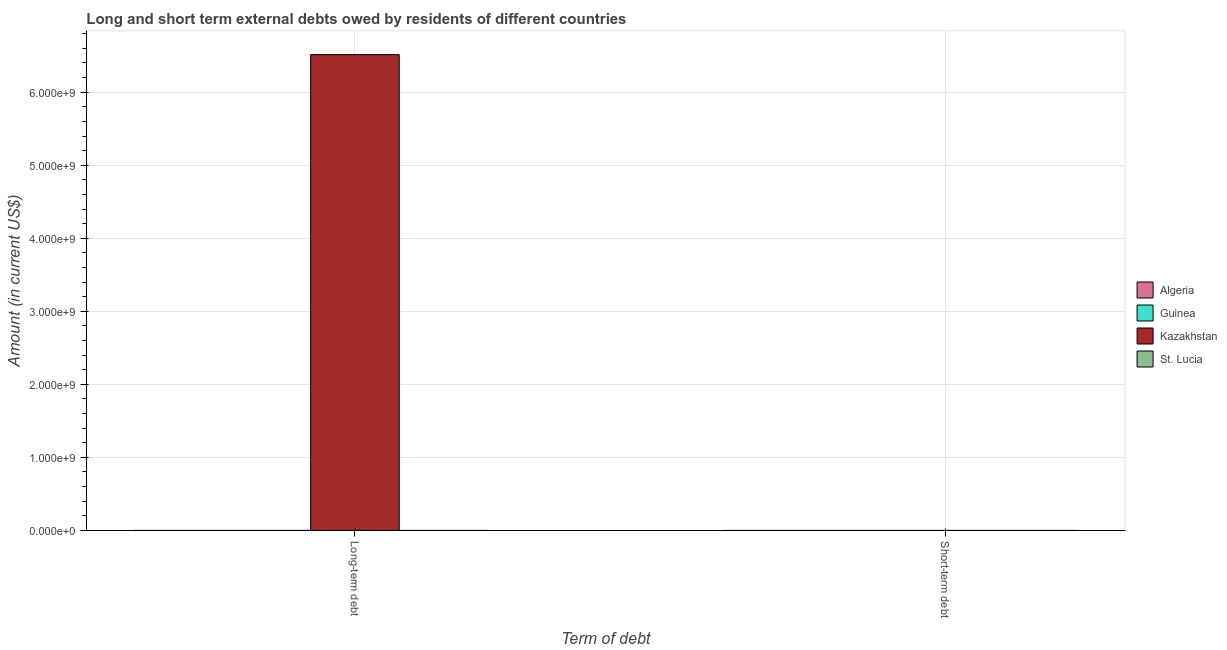Are the number of bars per tick equal to the number of legend labels?
Provide a succinct answer. No. Are the number of bars on each tick of the X-axis equal?
Your answer should be very brief. No. How many bars are there on the 2nd tick from the left?
Give a very brief answer. 0. How many bars are there on the 2nd tick from the right?
Offer a terse response. 1. What is the label of the 1st group of bars from the left?
Your response must be concise. Long-term debt. Across all countries, what is the maximum long-term debts owed by residents?
Provide a succinct answer. 6.51e+09. Across all countries, what is the minimum short-term debts owed by residents?
Make the answer very short. 0. In which country was the long-term debts owed by residents maximum?
Your answer should be very brief. Kazakhstan. What is the total short-term debts owed by residents in the graph?
Your answer should be compact. 0. What is the average long-term debts owed by residents per country?
Provide a succinct answer. 1.63e+09. In how many countries, is the short-term debts owed by residents greater than 2200000000 US$?
Your answer should be very brief. 0. How many countries are there in the graph?
Make the answer very short. 4. Are the values on the major ticks of Y-axis written in scientific E-notation?
Your response must be concise. Yes. Does the graph contain any zero values?
Offer a very short reply. Yes. Does the graph contain grids?
Provide a succinct answer. Yes. How many legend labels are there?
Keep it short and to the point. 4. How are the legend labels stacked?
Ensure brevity in your answer.  Vertical. What is the title of the graph?
Your answer should be very brief. Long and short term external debts owed by residents of different countries. What is the label or title of the X-axis?
Provide a short and direct response. Term of debt. What is the Amount (in current US$) in Kazakhstan in Long-term debt?
Ensure brevity in your answer.  6.51e+09. What is the Amount (in current US$) of St. Lucia in Long-term debt?
Provide a succinct answer. 0. What is the Amount (in current US$) in Algeria in Short-term debt?
Offer a very short reply. 0. What is the Amount (in current US$) in Guinea in Short-term debt?
Offer a very short reply. 0. What is the Amount (in current US$) of Kazakhstan in Short-term debt?
Your answer should be compact. 0. What is the Amount (in current US$) in St. Lucia in Short-term debt?
Your answer should be very brief. 0. Across all Term of debt, what is the maximum Amount (in current US$) of Kazakhstan?
Provide a short and direct response. 6.51e+09. Across all Term of debt, what is the minimum Amount (in current US$) of Kazakhstan?
Give a very brief answer. 0. What is the total Amount (in current US$) of Algeria in the graph?
Provide a short and direct response. 0. What is the total Amount (in current US$) in Guinea in the graph?
Offer a very short reply. 0. What is the total Amount (in current US$) of Kazakhstan in the graph?
Provide a succinct answer. 6.51e+09. What is the total Amount (in current US$) of St. Lucia in the graph?
Provide a succinct answer. 0. What is the average Amount (in current US$) in Algeria per Term of debt?
Offer a very short reply. 0. What is the average Amount (in current US$) in Guinea per Term of debt?
Your answer should be compact. 0. What is the average Amount (in current US$) of Kazakhstan per Term of debt?
Provide a short and direct response. 3.26e+09. What is the average Amount (in current US$) of St. Lucia per Term of debt?
Provide a succinct answer. 0. What is the difference between the highest and the lowest Amount (in current US$) of Kazakhstan?
Your response must be concise. 6.51e+09. 